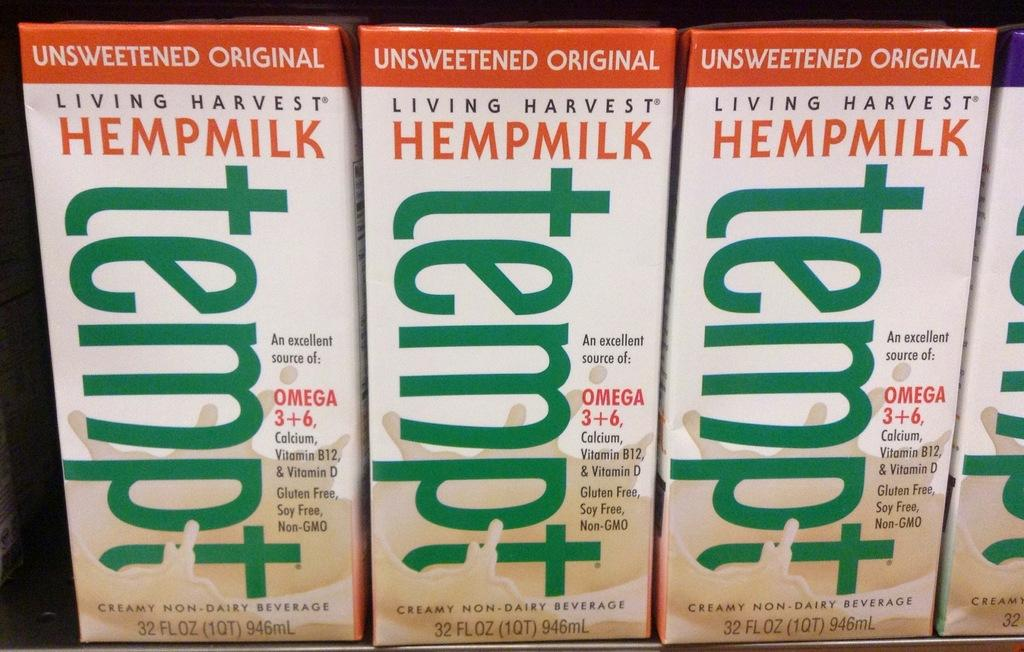Provide a one-sentence caption for the provided image. 3 containers of unsweetened orginal living harvest hempmilk. 